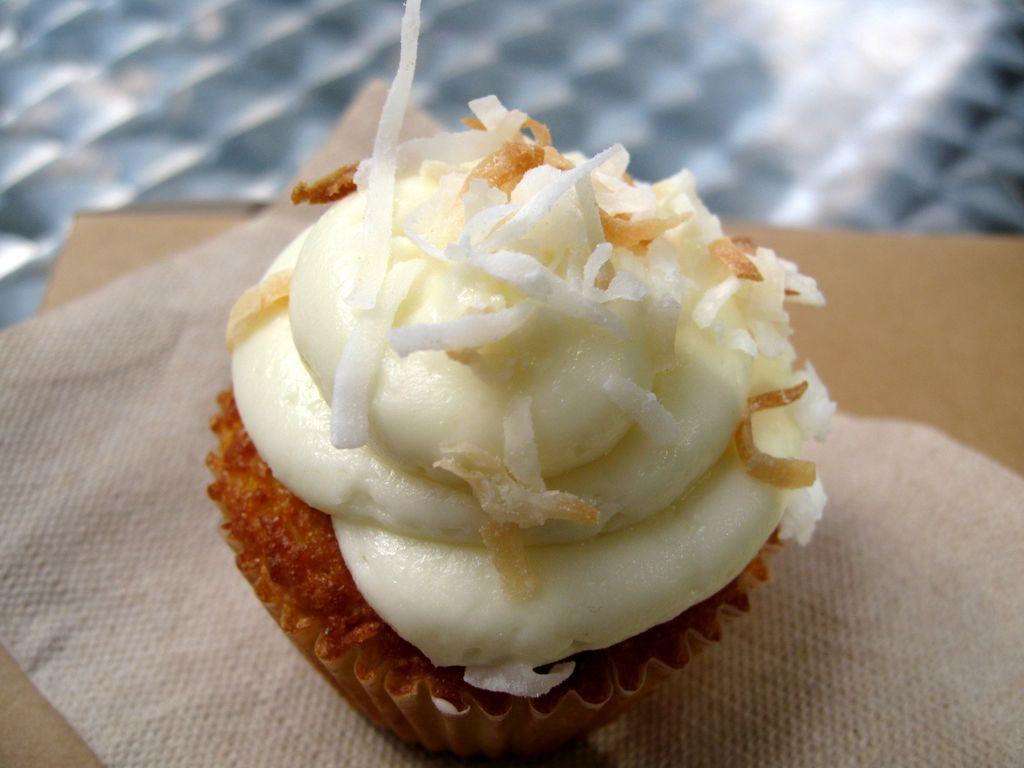In one or two sentences, can you explain what this image depicts? In this image, I can see a cupcake on a tissue, which is on an object. There is a blurred background. 